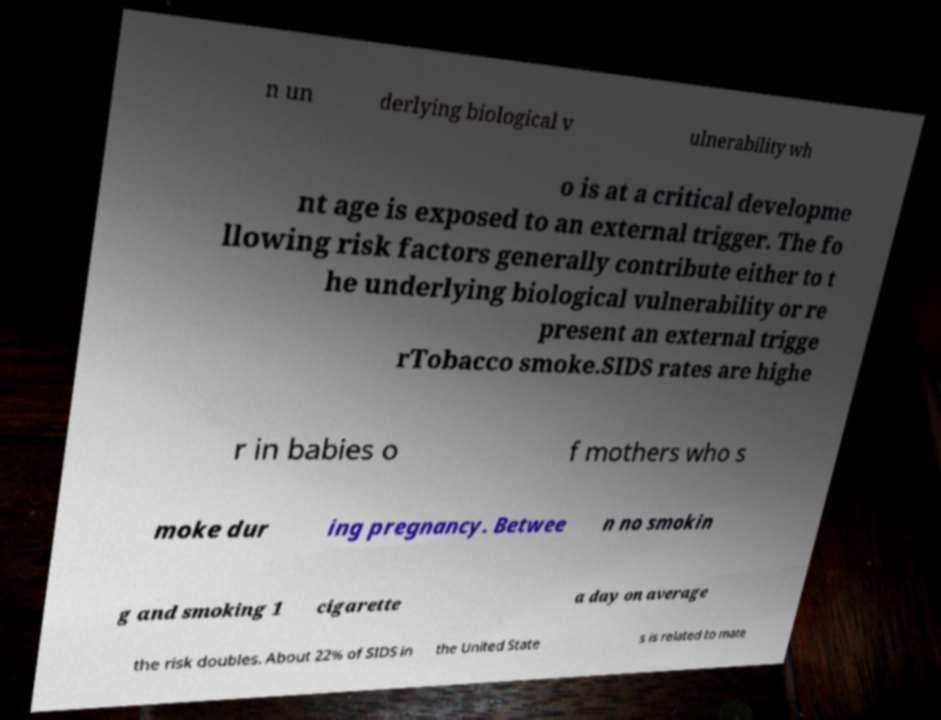For documentation purposes, I need the text within this image transcribed. Could you provide that? n un derlying biological v ulnerability wh o is at a critical developme nt age is exposed to an external trigger. The fo llowing risk factors generally contribute either to t he underlying biological vulnerability or re present an external trigge rTobacco smoke.SIDS rates are highe r in babies o f mothers who s moke dur ing pregnancy. Betwee n no smokin g and smoking 1 cigarette a day on average the risk doubles. About 22% of SIDS in the United State s is related to mate 